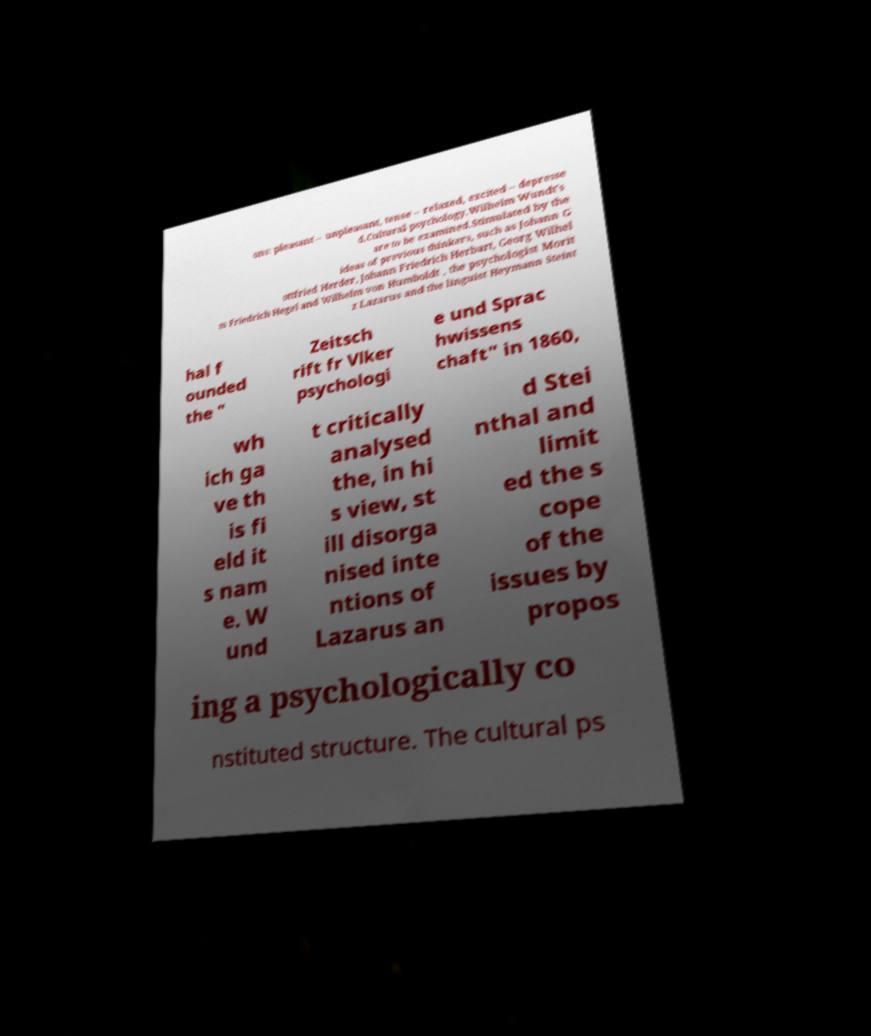Can you accurately transcribe the text from the provided image for me? ons: pleasant – unpleasant, tense – relaxed, excited – depresse d.Cultural psychology.Wilhelm Wundt's are to be examined.Stimulated by the ideas of previous thinkers, such as Johann G ottfried Herder, Johann Friedrich Herbart, Georg Wilhel m Friedrich Hegel and Wilhelm von Humboldt , the psychologist Morit z Lazarus and the linguist Heymann Steint hal f ounded the " Zeitsch rift fr Vlker psychologi e und Sprac hwissens chaft" in 1860, wh ich ga ve th is fi eld it s nam e. W und t critically analysed the, in hi s view, st ill disorga nised inte ntions of Lazarus an d Stei nthal and limit ed the s cope of the issues by propos ing a psychologically co nstituted structure. The cultural ps 